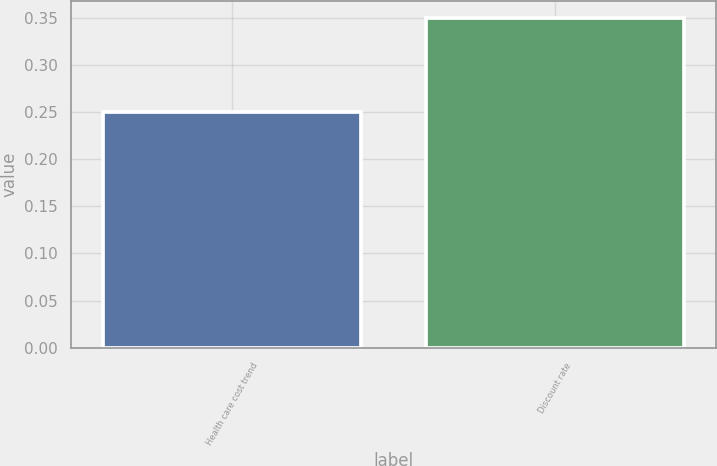Convert chart. <chart><loc_0><loc_0><loc_500><loc_500><bar_chart><fcel>Health care cost trend<fcel>Discount rate<nl><fcel>0.25<fcel>0.35<nl></chart> 